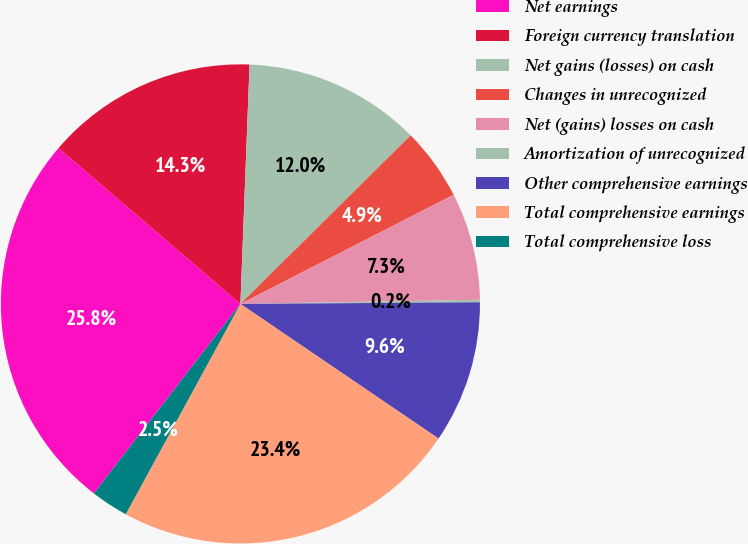Convert chart. <chart><loc_0><loc_0><loc_500><loc_500><pie_chart><fcel>Net earnings<fcel>Foreign currency translation<fcel>Net gains (losses) on cash<fcel>Changes in unrecognized<fcel>Net (gains) losses on cash<fcel>Amortization of unrecognized<fcel>Other comprehensive earnings<fcel>Total comprehensive earnings<fcel>Total comprehensive loss<nl><fcel>25.8%<fcel>14.33%<fcel>11.97%<fcel>4.89%<fcel>7.25%<fcel>0.17%<fcel>9.61%<fcel>23.44%<fcel>2.53%<nl></chart> 